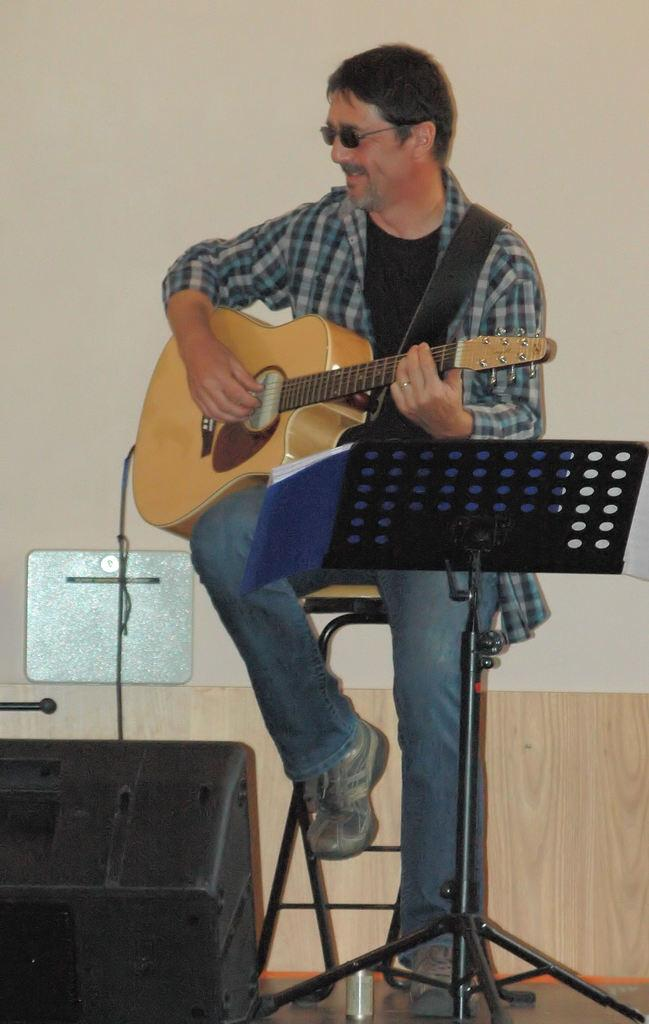What is the man in the image doing? The man is sitting in the image. What is the man holding in the image? The man is holding a guitar in the image. What is in front of the man in the image? There is a stand in front of the man in the image. What can be seen in the background of the image? There is a wall in the background of the image. How many lizards are crawling on the wall in the image? There are no lizards visible in the image; only the man, the guitar, the stand, and the wall are present. What type of soap is the man using to clean the guitar in the image? There is no soap or cleaning activity depicted in the image; the man is simply holding a guitar. 